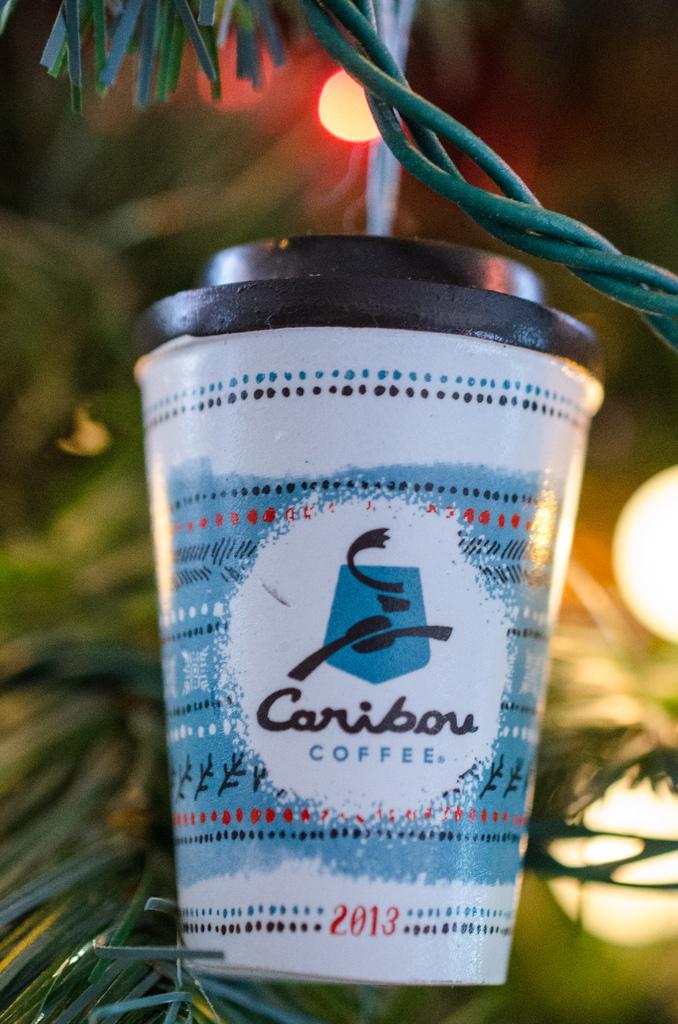What year was this?
Ensure brevity in your answer.  2013. 